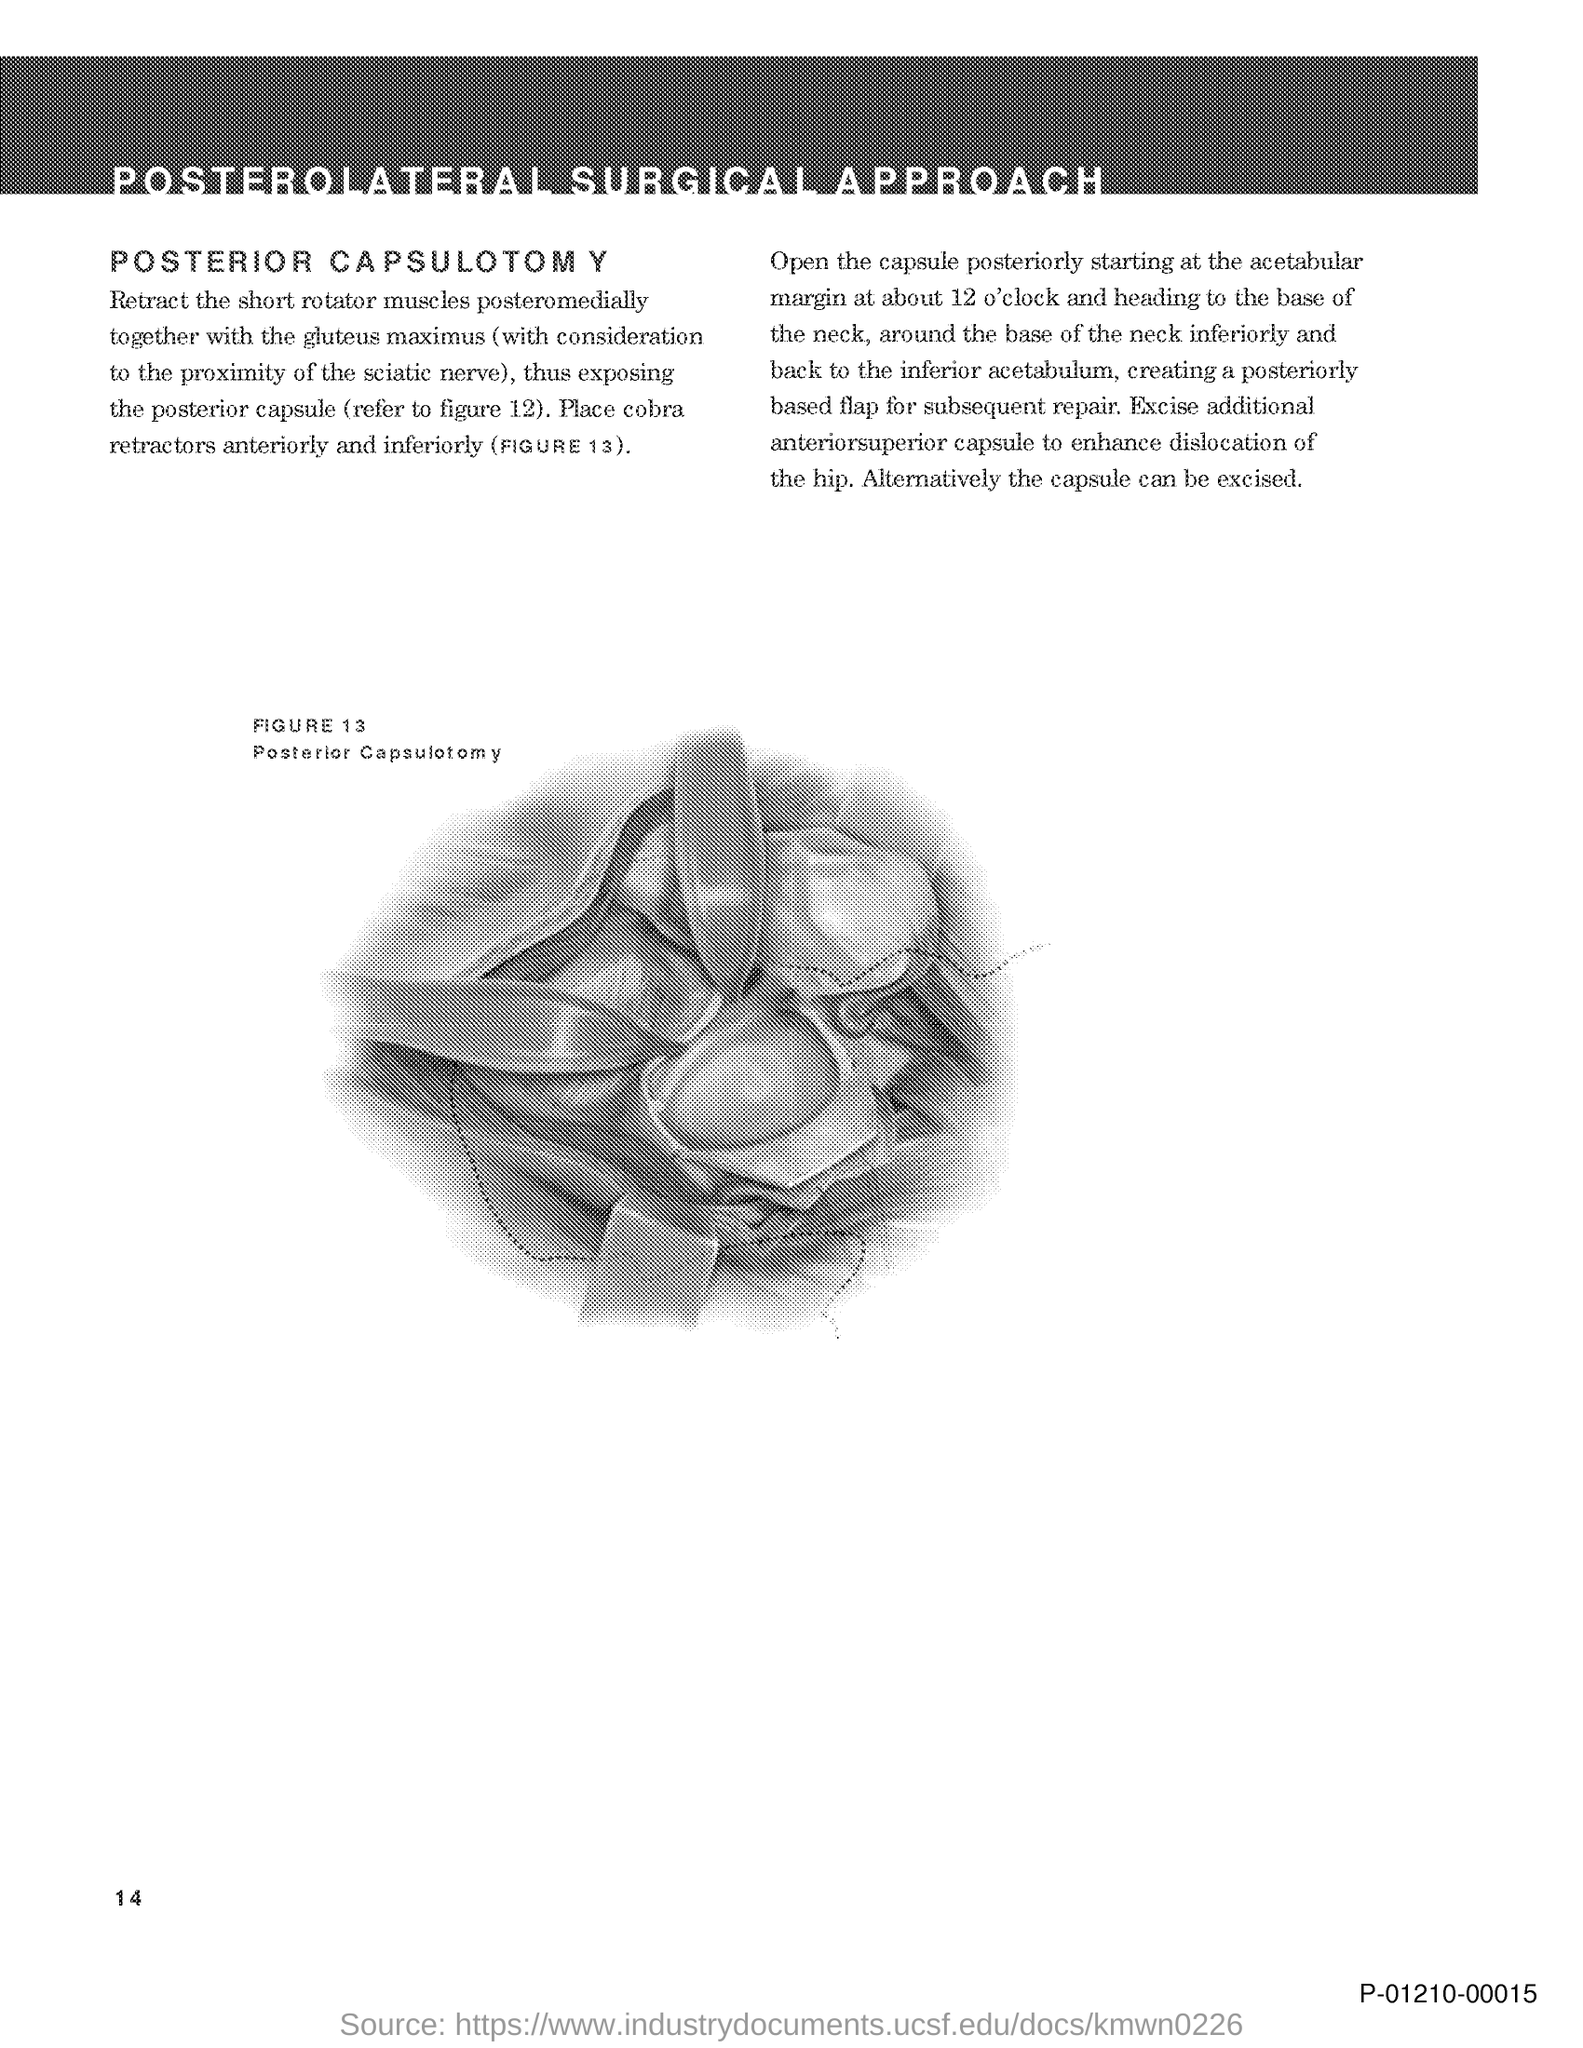What is the title of the document?
Provide a succinct answer. Posterolateral Surgical Approach. 